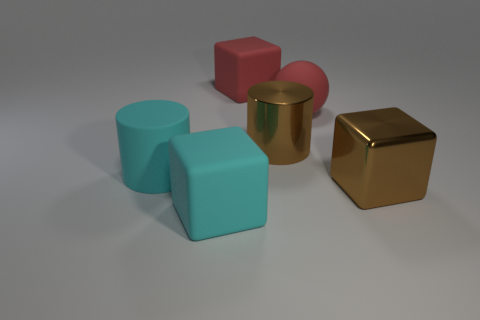Add 3 matte spheres. How many objects exist? 9 Subtract all balls. How many objects are left? 5 Add 5 balls. How many balls are left? 6 Add 5 big red rubber balls. How many big red rubber balls exist? 6 Subtract 1 red spheres. How many objects are left? 5 Subtract all metallic cubes. Subtract all green shiny cylinders. How many objects are left? 5 